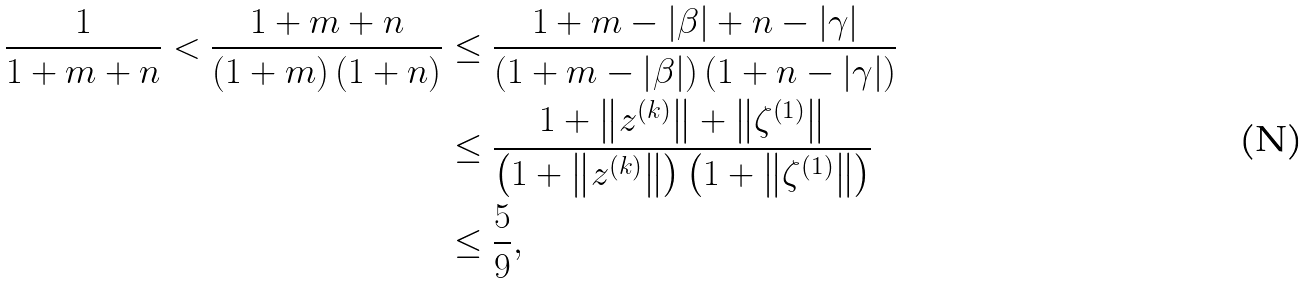<formula> <loc_0><loc_0><loc_500><loc_500>\frac { 1 } { 1 + m + n } < \frac { 1 + m + n } { \left ( 1 + m \right ) \left ( 1 + n \right ) } & \leq \frac { 1 + m - \left | \beta \right | + n - \left | \gamma \right | } { \left ( 1 + m - \left | \beta \right | \right ) \left ( 1 + n - \left | \gamma \right | \right ) } \\ & \leq \frac { 1 + \left \| z ^ { \left ( k \right ) } \right \| + \left \| \zeta ^ { \left ( 1 \right ) } \right \| } { \left ( 1 + \left \| z ^ { \left ( k \right ) } \right \| \right ) \left ( 1 + \left \| \zeta ^ { \left ( 1 \right ) } \right \| \right ) } \\ & \leq \frac { 5 } { 9 } ,</formula> 